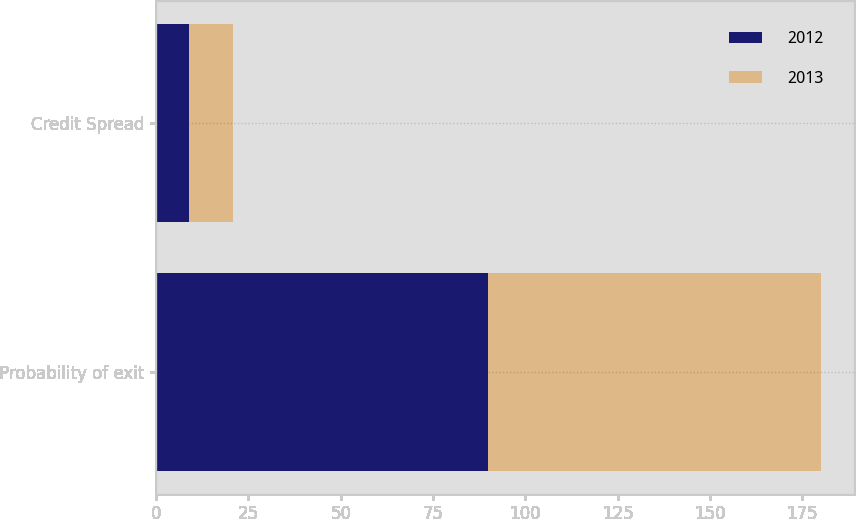Convert chart to OTSL. <chart><loc_0><loc_0><loc_500><loc_500><stacked_bar_chart><ecel><fcel>Probability of exit<fcel>Credit Spread<nl><fcel>2012<fcel>90<fcel>8.9<nl><fcel>2013<fcel>90<fcel>11.94<nl></chart> 